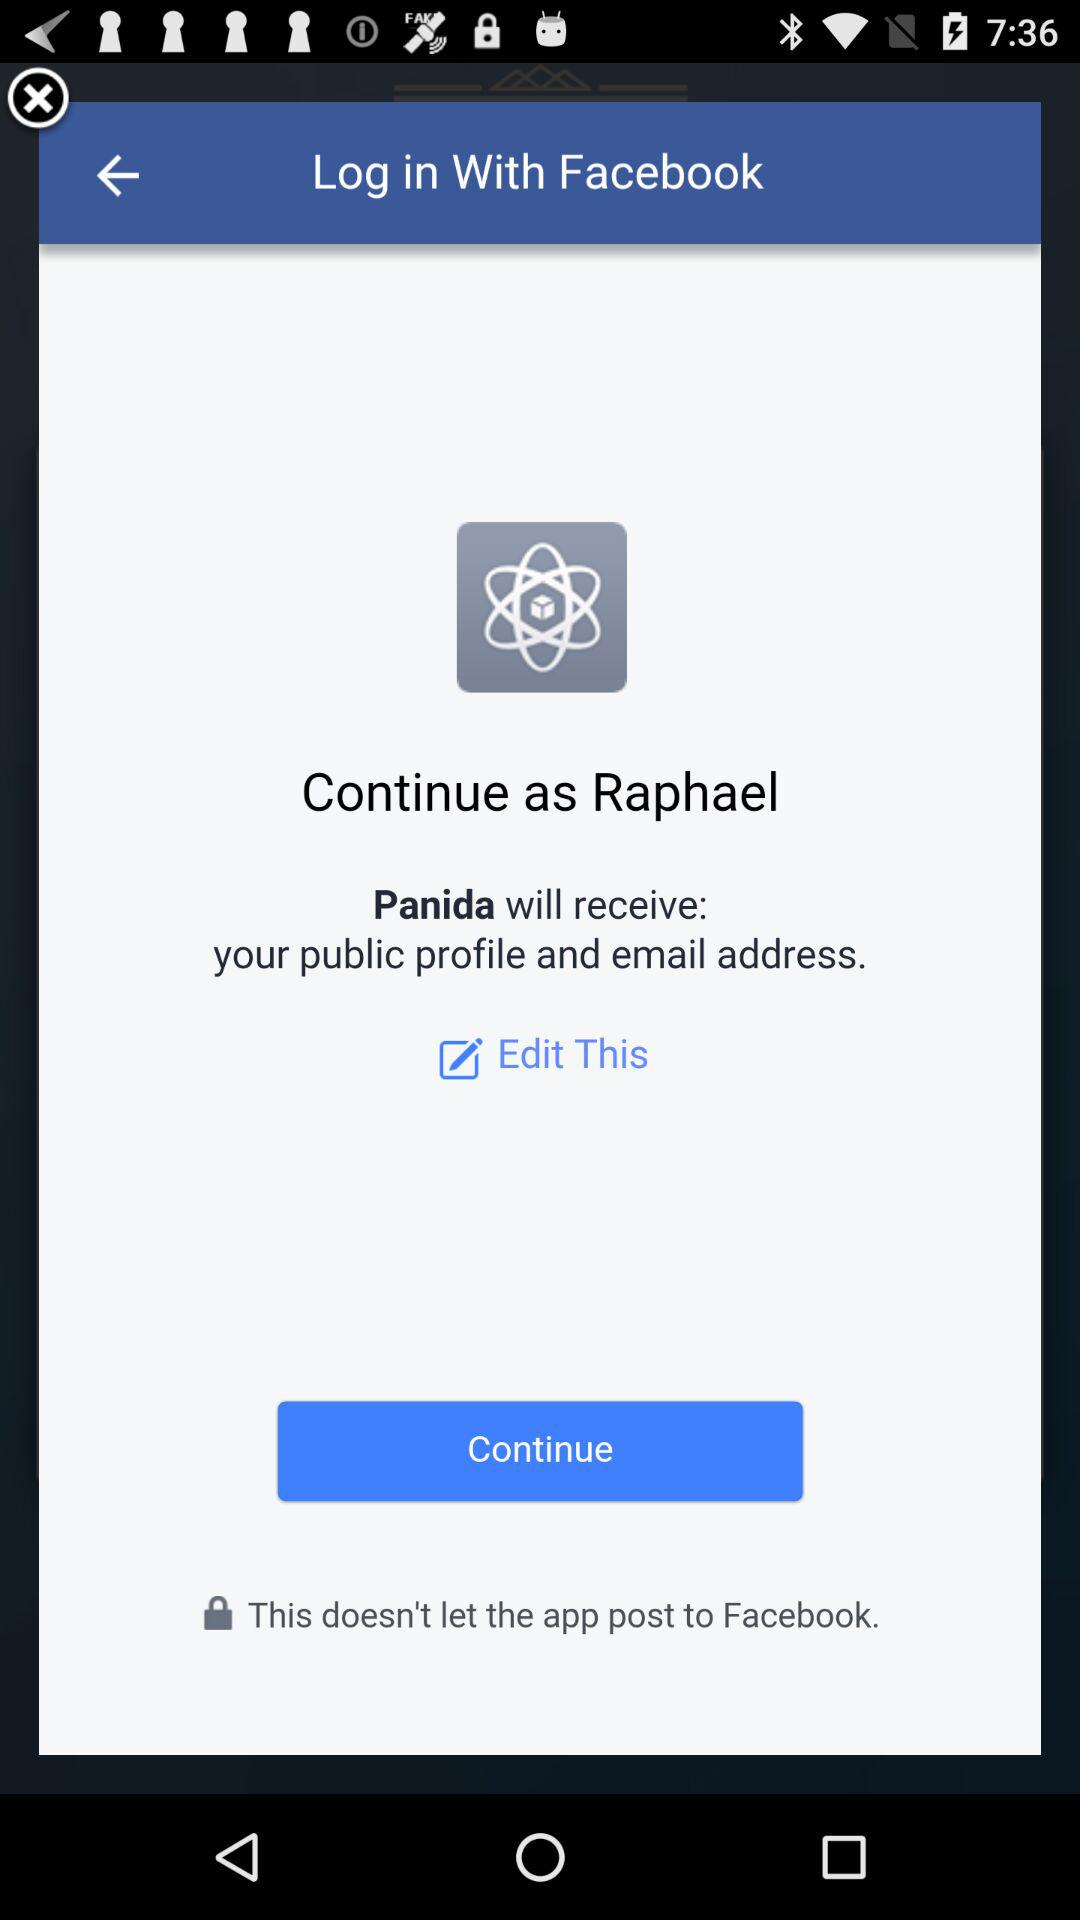What is the application name? The application names are "Panida" and "Facebook". 